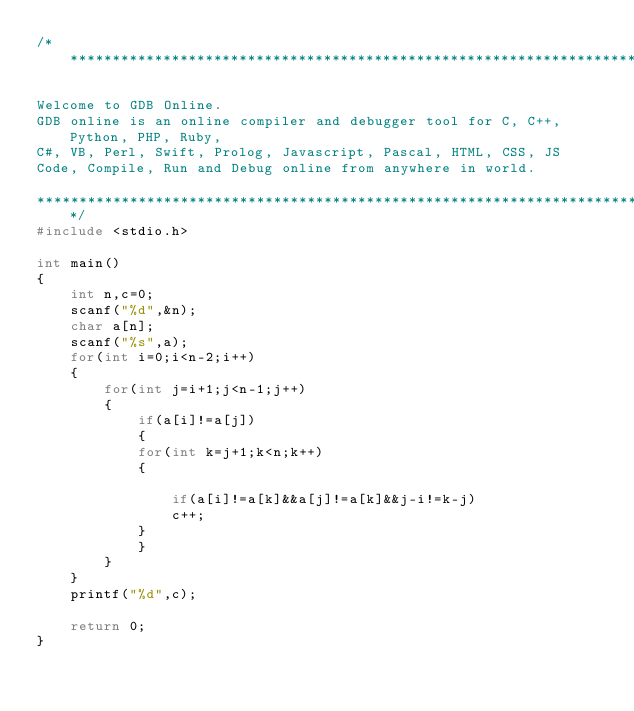Convert code to text. <code><loc_0><loc_0><loc_500><loc_500><_C++_>/******************************************************************************

Welcome to GDB Online.
GDB online is an online compiler and debugger tool for C, C++, Python, PHP, Ruby, 
C#, VB, Perl, Swift, Prolog, Javascript, Pascal, HTML, CSS, JS
Code, Compile, Run and Debug online from anywhere in world.

*******************************************************************************/
#include <stdio.h>

int main()
{
    int n,c=0;
    scanf("%d",&n);
    char a[n];
    scanf("%s",a);
    for(int i=0;i<n-2;i++)
    {
        for(int j=i+1;j<n-1;j++)
        {
            if(a[i]!=a[j])
            {
            for(int k=j+1;k<n;k++)
            {
                
                if(a[i]!=a[k]&&a[j]!=a[k]&&j-i!=k-j)
                c++;
            }
            }
        }
    }
    printf("%d",c);

    return 0;
}
</code> 